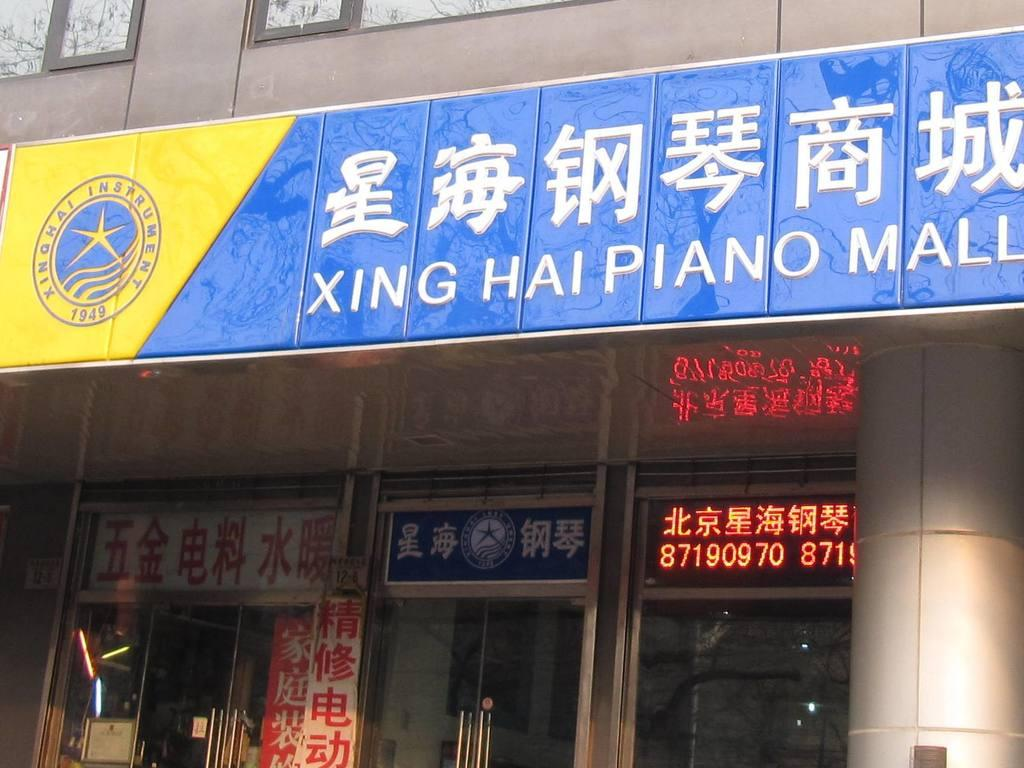What type of structure is visible in the image? There is a building in the image. What architectural features can be seen on the building? There are windows and pillars visible on the building. What additional objects are present in the image? There are name boards in the image. What type of mitten is being used to hold the feast in the image? There is no mitten or feast present in the image. What position is the building in the image? The building is stationary in the image, and there is no indication of its position relative to other structures or objects. 